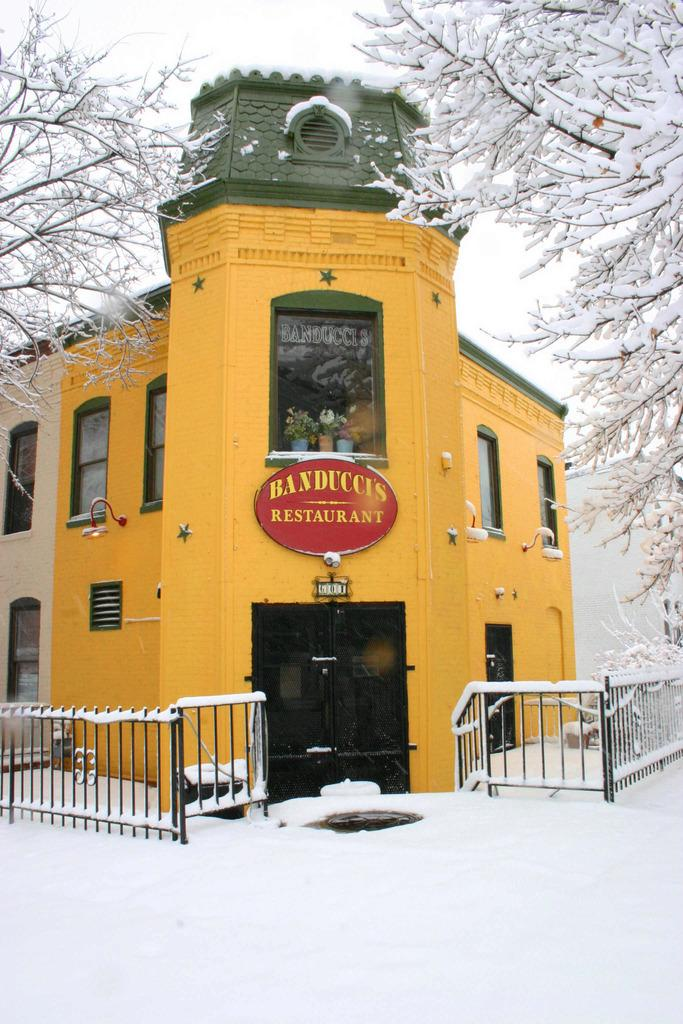What type of weather is depicted in the image? The image contains snow, indicating a cold or wintry weather. What type of structure can be seen in the image? There is a building in the image. What architectural feature is present in the image? There is a fence in the image. What part of the building can be used for entering or exiting? There is a door in the image. What can be used for displaying information or advertisements? There is a board in the image. What allows natural light to enter the building? There are windows in the image. What type of vegetation is present in the image? There are trees in the image. What is visible in the background of the image? The sky is visible in the background of the image. What type of toys can be seen playing in the snow in the image? There are no toys present in the image; it depicts a snowy scene with a building, fence, door, board, windows, trees, and sky. 